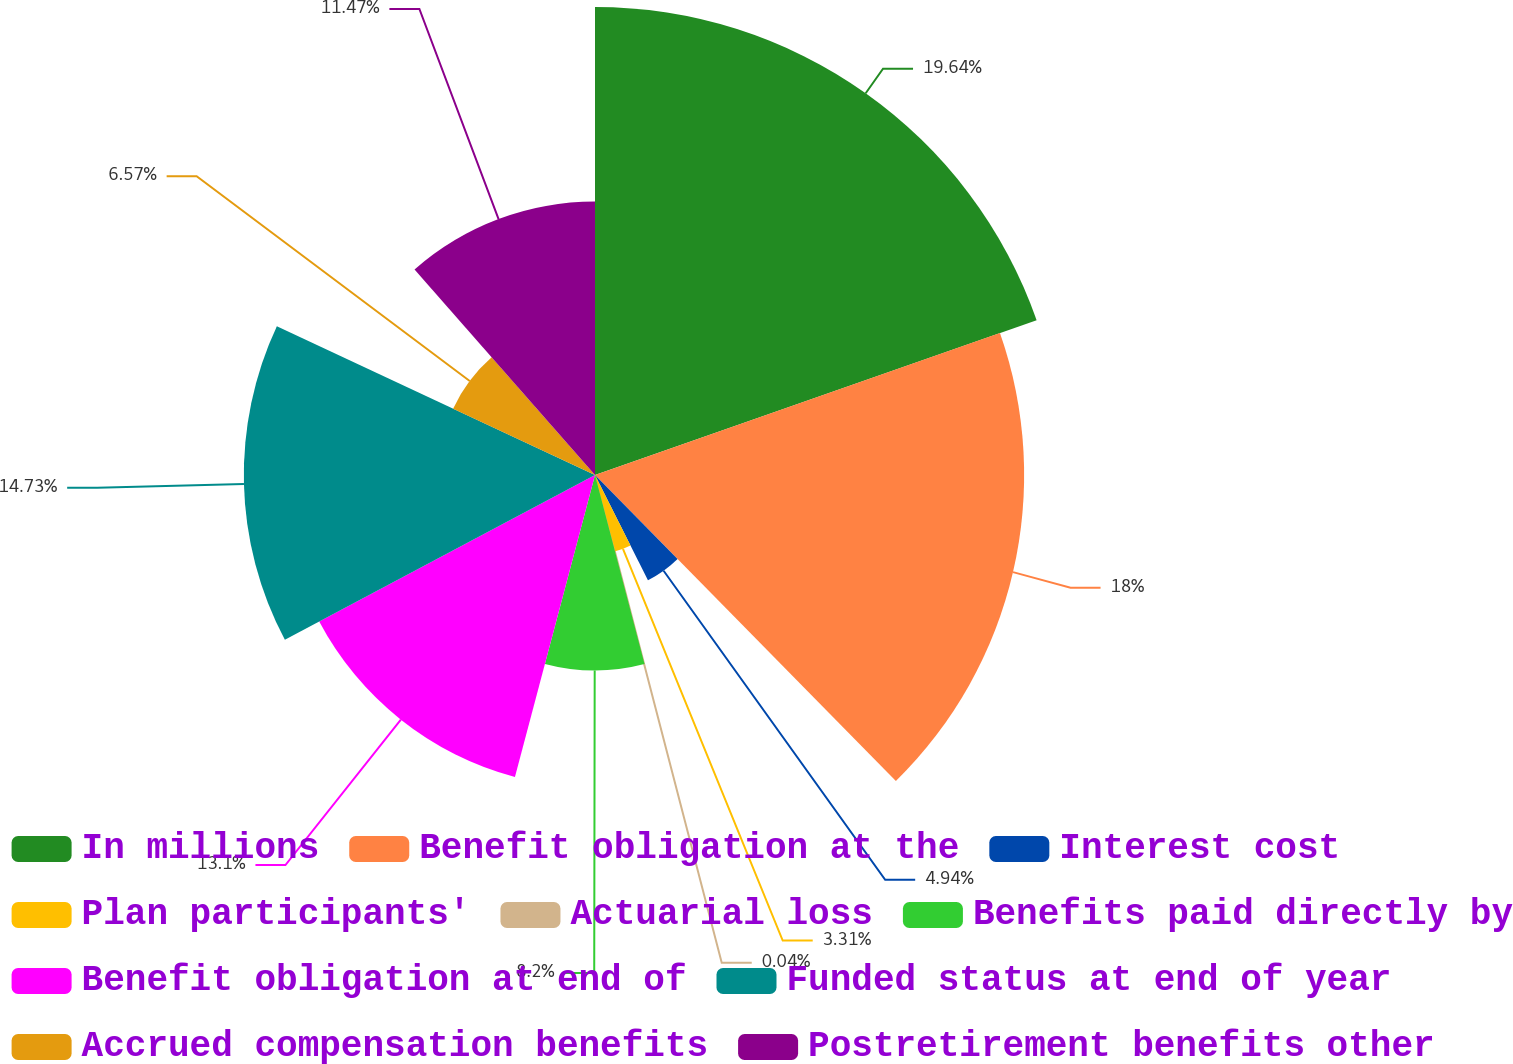<chart> <loc_0><loc_0><loc_500><loc_500><pie_chart><fcel>In millions<fcel>Benefit obligation at the<fcel>Interest cost<fcel>Plan participants'<fcel>Actuarial loss<fcel>Benefits paid directly by<fcel>Benefit obligation at end of<fcel>Funded status at end of year<fcel>Accrued compensation benefits<fcel>Postretirement benefits other<nl><fcel>19.63%<fcel>18.0%<fcel>4.94%<fcel>3.31%<fcel>0.04%<fcel>8.2%<fcel>13.1%<fcel>14.73%<fcel>6.57%<fcel>11.47%<nl></chart> 